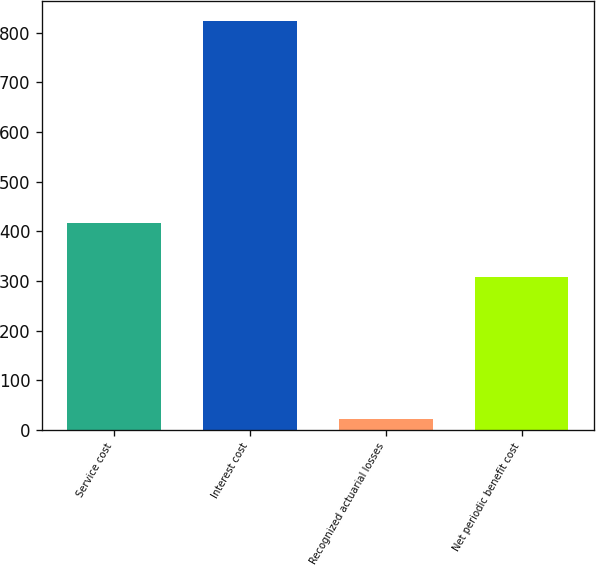<chart> <loc_0><loc_0><loc_500><loc_500><bar_chart><fcel>Service cost<fcel>Interest cost<fcel>Recognized actuarial losses<fcel>Net periodic benefit cost<nl><fcel>417<fcel>823<fcel>23<fcel>308<nl></chart> 